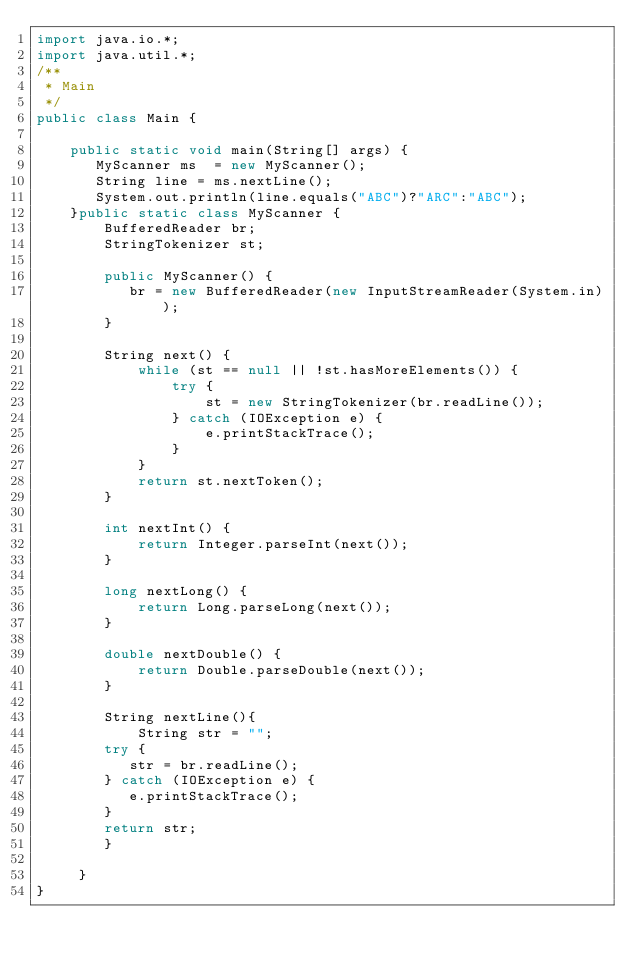Convert code to text. <code><loc_0><loc_0><loc_500><loc_500><_Java_>import java.io.*;
import java.util.*;
/**
 * Main
 */
public class Main {

    public static void main(String[] args) {
       MyScanner ms  = new MyScanner();
       String line = ms.nextLine();
       System.out.println(line.equals("ABC")?"ARC":"ABC");
    }public static class MyScanner {
        BufferedReader br;
        StringTokenizer st;
   
        public MyScanner() {
           br = new BufferedReader(new InputStreamReader(System.in));
        }
   
        String next() {
            while (st == null || !st.hasMoreElements()) {
                try {
                    st = new StringTokenizer(br.readLine());
                } catch (IOException e) {
                    e.printStackTrace();
                }
            }
            return st.nextToken();
        }
   
        int nextInt() {
            return Integer.parseInt(next());
        }
   
        long nextLong() {
            return Long.parseLong(next());
        }
   
        double nextDouble() {
            return Double.parseDouble(next());
        }
   
        String nextLine(){
            String str = "";
        try {
           str = br.readLine();
        } catch (IOException e) {
           e.printStackTrace();
        }
        return str;
        }
  
     }
}</code> 